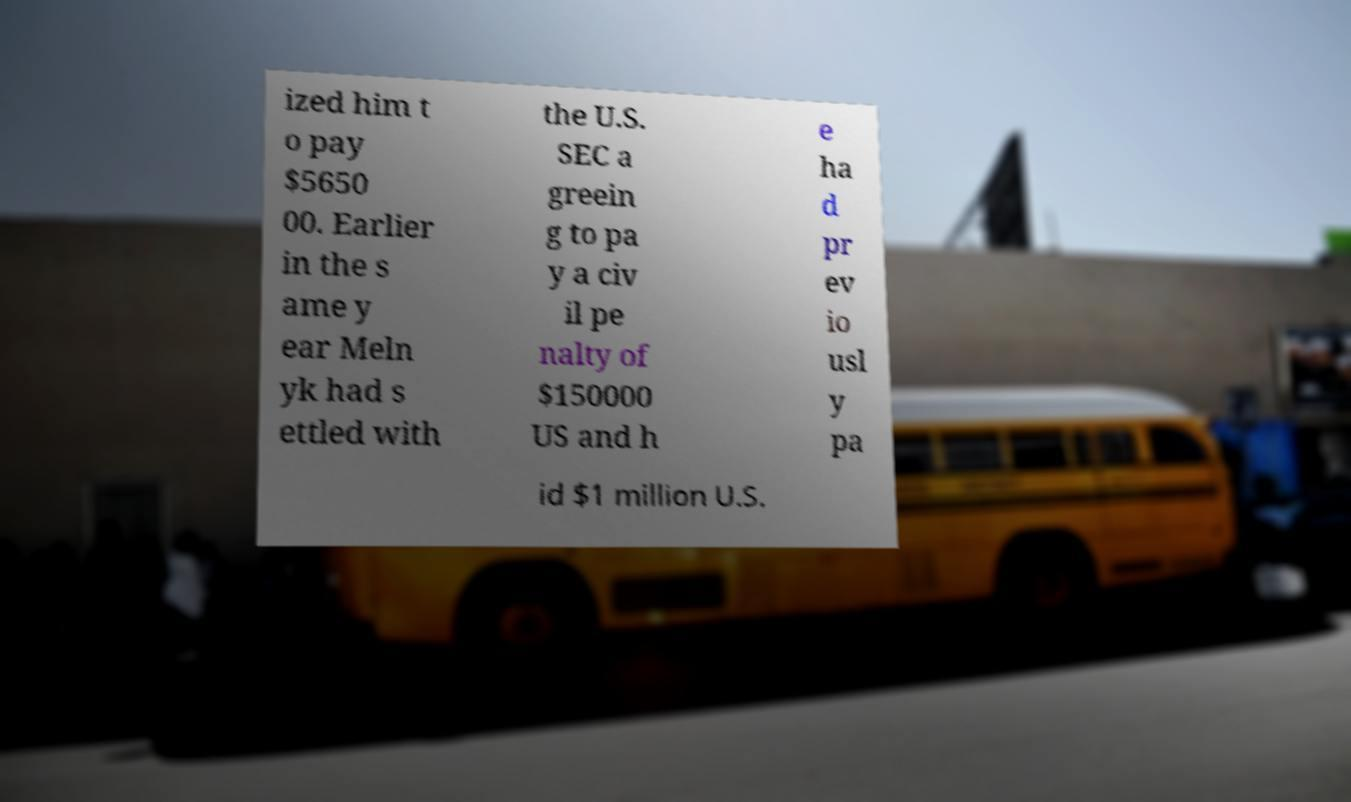Please read and relay the text visible in this image. What does it say? ized him t o pay $5650 00. Earlier in the s ame y ear Meln yk had s ettled with the U.S. SEC a greein g to pa y a civ il pe nalty of $150000 US and h e ha d pr ev io usl y pa id $1 million U.S. 